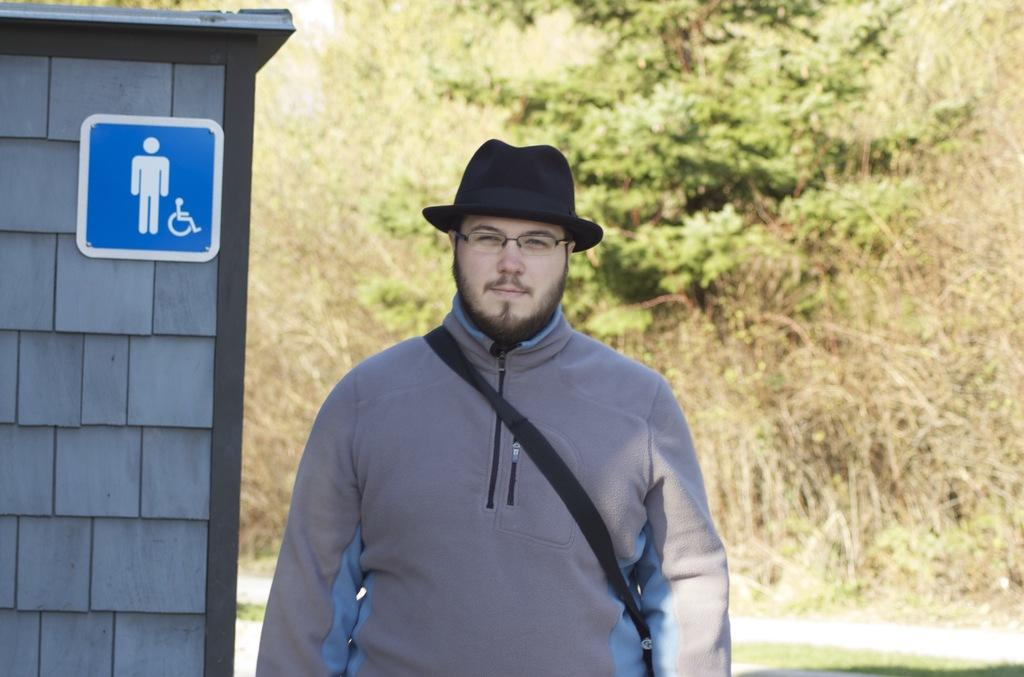What is the man in the image doing? The man is standing and smiling in the image. What type of clothing is the man wearing? The man is wearing a jerkin. What accessories can be seen on the man? The man is wearing spectacles and a hat. What is attached to the wall in the image? There is a signboard attached to a wall in the image. What can be seen in the background of the image? Trees are visible in the background of the image. What type of tub is visible in the image? There is no tub present in the image. What drink is the man holding in the image? The man is not holding any drink in the image. 